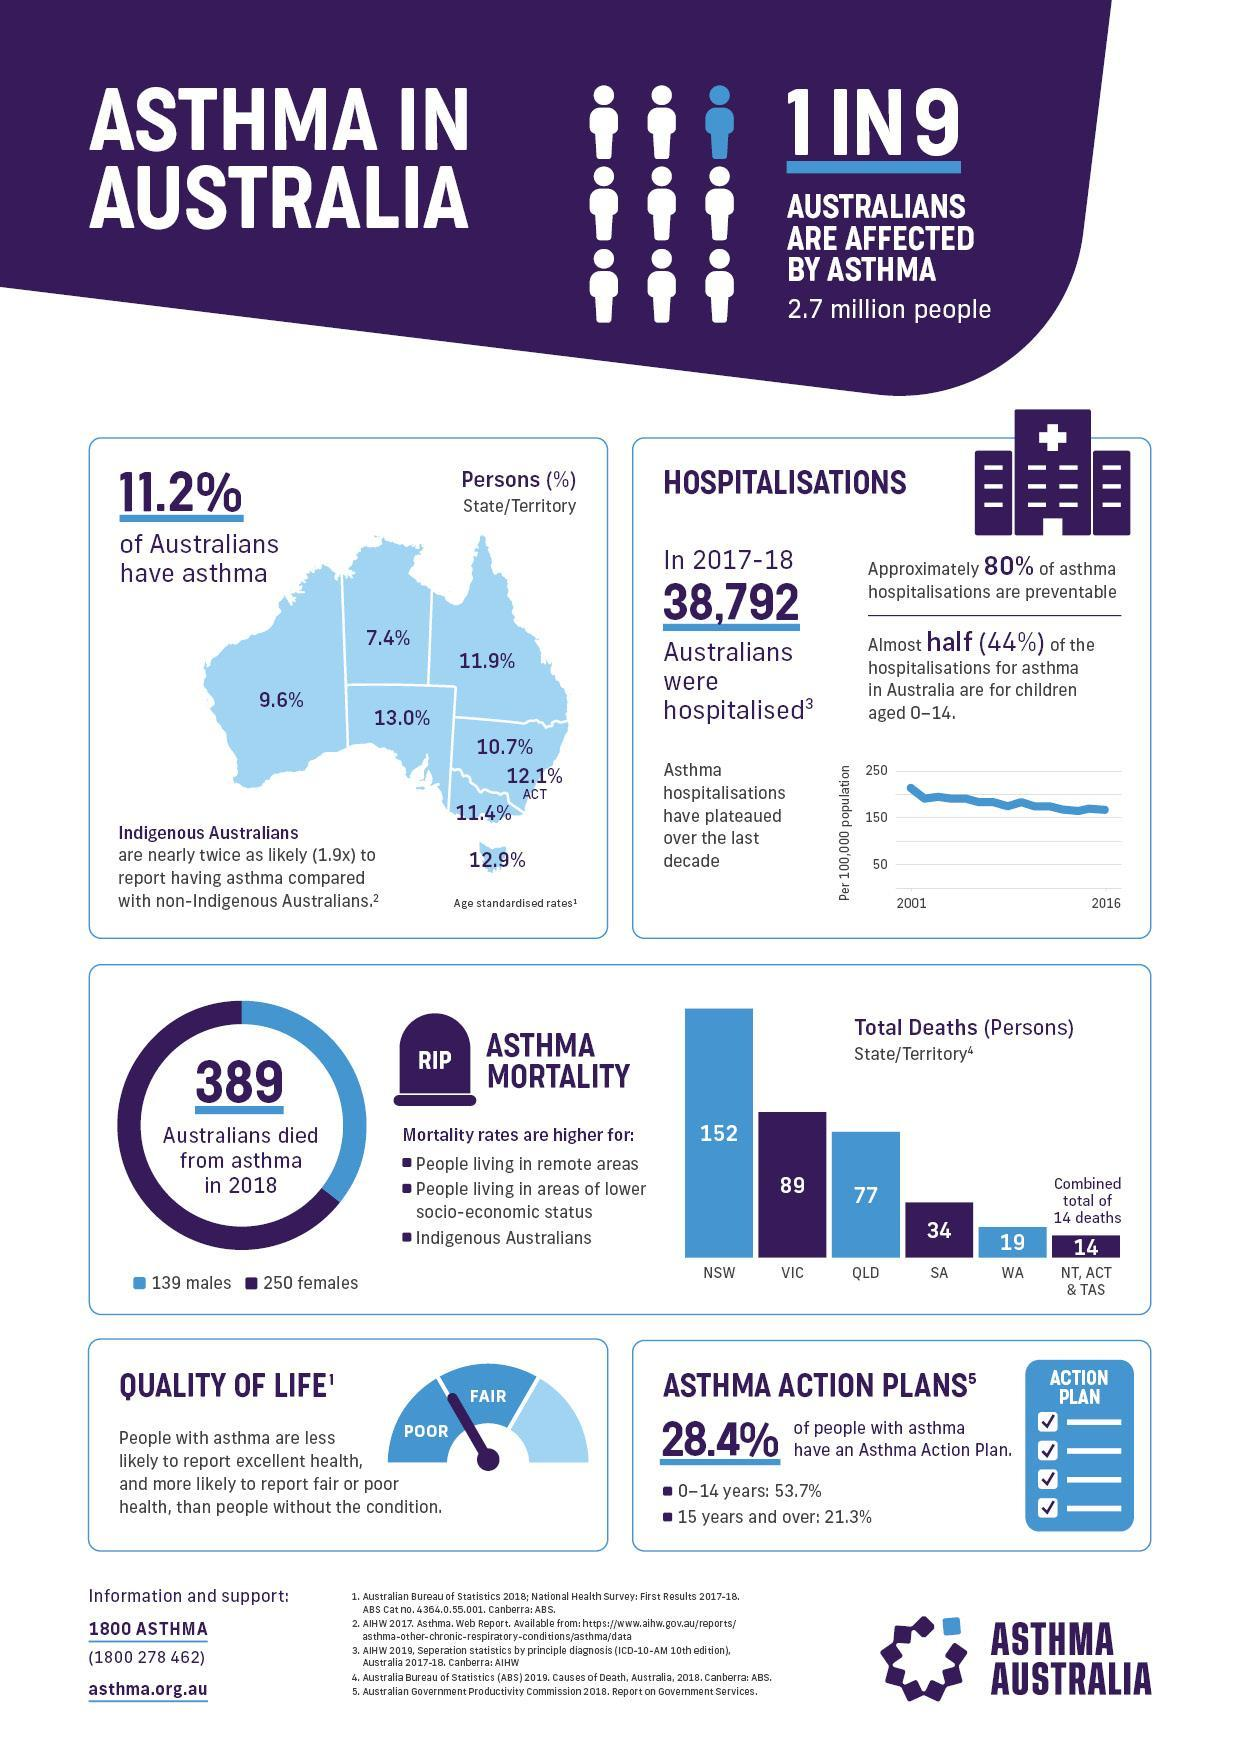What % of australians have Asthma in Tasmania
Answer the question with a short phrase. 12.9% How much higher is the number of female deaths compared to male death on 2018 111 What % of australians have Asthma in Western Australia 9.6% What is written of the headstone RIP What is the total deaths in Queensland 77 What % of australians have Asthma in Queensland and Victoria 23 Others that people living in areas of lower socio-economic status, where else is asthma mortality higher people living in remote areas, indegenous australians 